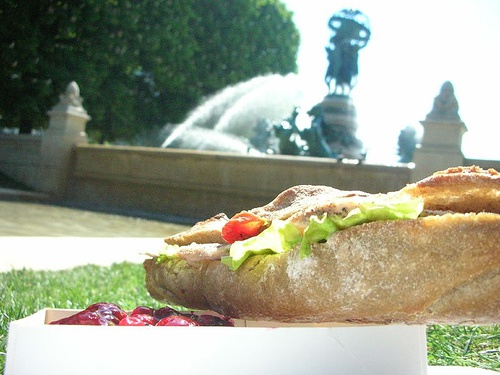Describe the objects in this image and their specific colors. I can see a sandwich in black, tan, gray, beige, and khaki tones in this image. 